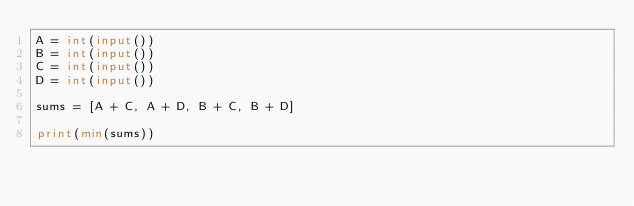<code> <loc_0><loc_0><loc_500><loc_500><_Python_>A = int(input())
B = int(input())
C = int(input())
D = int(input())

sums = [A + C, A + D, B + C, B + D]

print(min(sums))</code> 